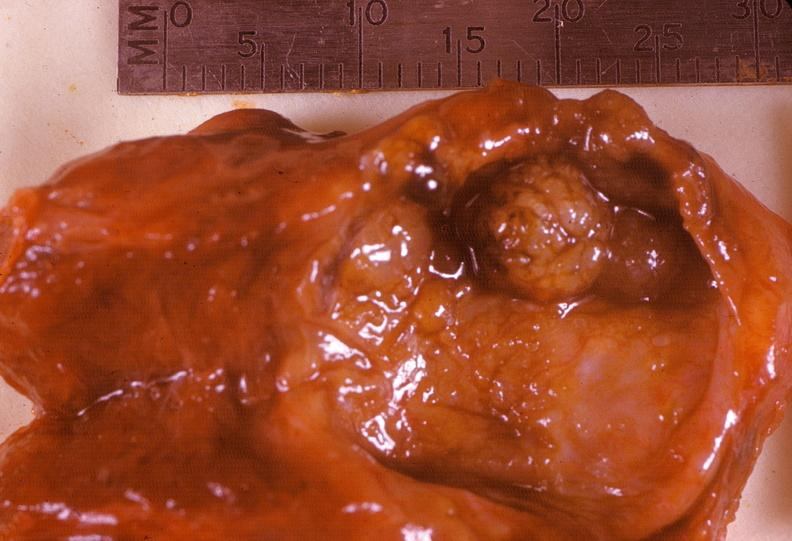does this image show thyroid, follicular adenoma, cystic?
Answer the question using a single word or phrase. Yes 